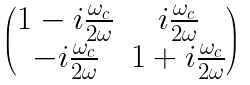Convert formula to latex. <formula><loc_0><loc_0><loc_500><loc_500>\begin{pmatrix} 1 - i \frac { \omega _ { c } } { 2 \omega } & i \frac { \omega _ { c } } { 2 \omega } \\ - i \frac { \omega _ { c } } { 2 \omega } & 1 + i \frac { \omega _ { c } } { 2 \omega } \\ \end{pmatrix}</formula> 